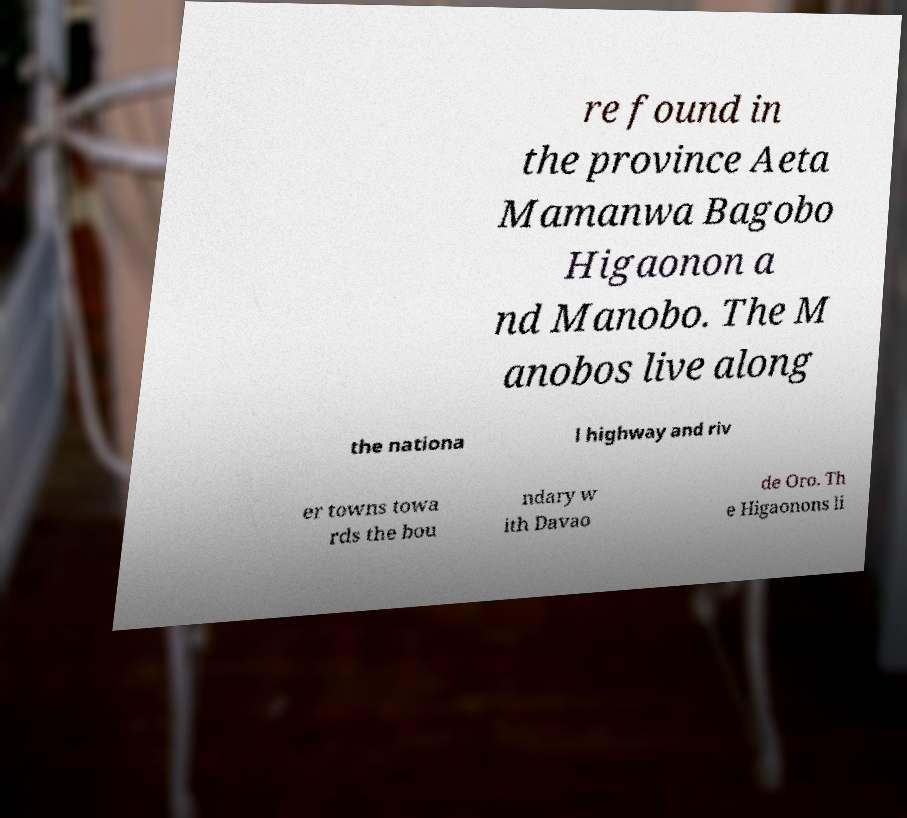There's text embedded in this image that I need extracted. Can you transcribe it verbatim? re found in the province Aeta Mamanwa Bagobo Higaonon a nd Manobo. The M anobos live along the nationa l highway and riv er towns towa rds the bou ndary w ith Davao de Oro. Th e Higaonons li 